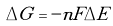<formula> <loc_0><loc_0><loc_500><loc_500>\Delta G = - n F \Delta E</formula> 